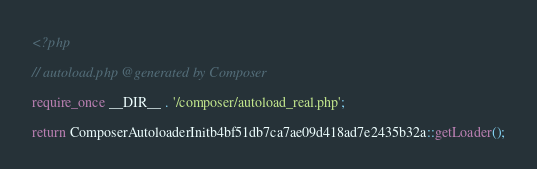Convert code to text. <code><loc_0><loc_0><loc_500><loc_500><_PHP_><?php

// autoload.php @generated by Composer

require_once __DIR__ . '/composer/autoload_real.php';

return ComposerAutoloaderInitb4bf51db7ca7ae09d418ad7e2435b32a::getLoader();
</code> 